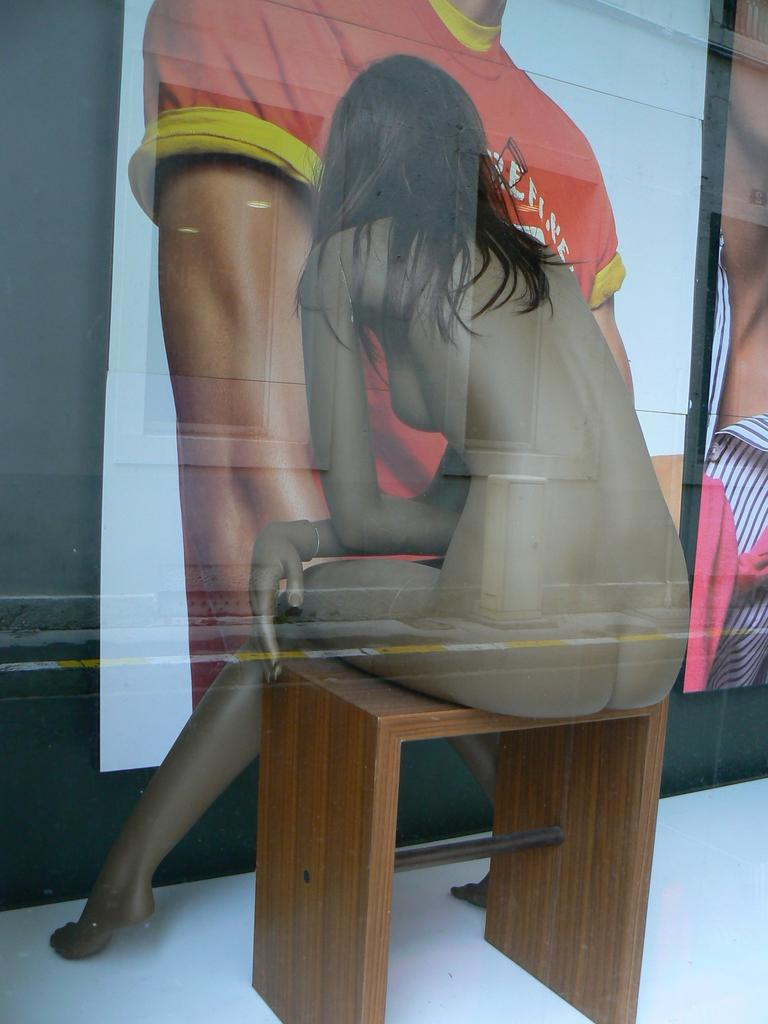What is the main subject of the image? There is a statue of a woman in the image. What is the woman in the statue wearing? The woman is not wearing a dress. What is the woman sitting on in the image? The woman is sitting on a wooden stool. What can be seen on the wall in front of the statue? There are posters on the wall in front of the statue. What type of pet can be seen interacting with the statue in the image? There is no pet present in the image; it only features a statue of a woman sitting on a wooden stool with posters on the wall in front of it. 